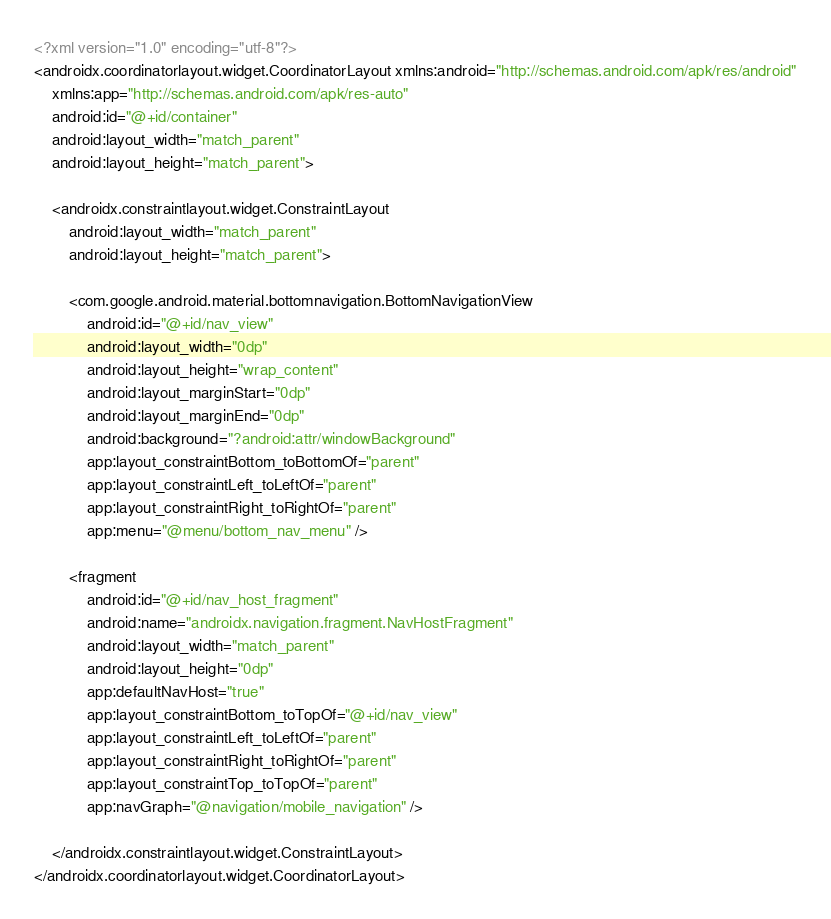Convert code to text. <code><loc_0><loc_0><loc_500><loc_500><_XML_><?xml version="1.0" encoding="utf-8"?>
<androidx.coordinatorlayout.widget.CoordinatorLayout xmlns:android="http://schemas.android.com/apk/res/android"
    xmlns:app="http://schemas.android.com/apk/res-auto"
    android:id="@+id/container"
    android:layout_width="match_parent"
    android:layout_height="match_parent">

    <androidx.constraintlayout.widget.ConstraintLayout
        android:layout_width="match_parent"
        android:layout_height="match_parent">

        <com.google.android.material.bottomnavigation.BottomNavigationView
            android:id="@+id/nav_view"
            android:layout_width="0dp"
            android:layout_height="wrap_content"
            android:layout_marginStart="0dp"
            android:layout_marginEnd="0dp"
            android:background="?android:attr/windowBackground"
            app:layout_constraintBottom_toBottomOf="parent"
            app:layout_constraintLeft_toLeftOf="parent"
            app:layout_constraintRight_toRightOf="parent"
            app:menu="@menu/bottom_nav_menu" />

        <fragment
            android:id="@+id/nav_host_fragment"
            android:name="androidx.navigation.fragment.NavHostFragment"
            android:layout_width="match_parent"
            android:layout_height="0dp"
            app:defaultNavHost="true"
            app:layout_constraintBottom_toTopOf="@+id/nav_view"
            app:layout_constraintLeft_toLeftOf="parent"
            app:layout_constraintRight_toRightOf="parent"
            app:layout_constraintTop_toTopOf="parent"
            app:navGraph="@navigation/mobile_navigation" />

    </androidx.constraintlayout.widget.ConstraintLayout>
</androidx.coordinatorlayout.widget.CoordinatorLayout>
</code> 